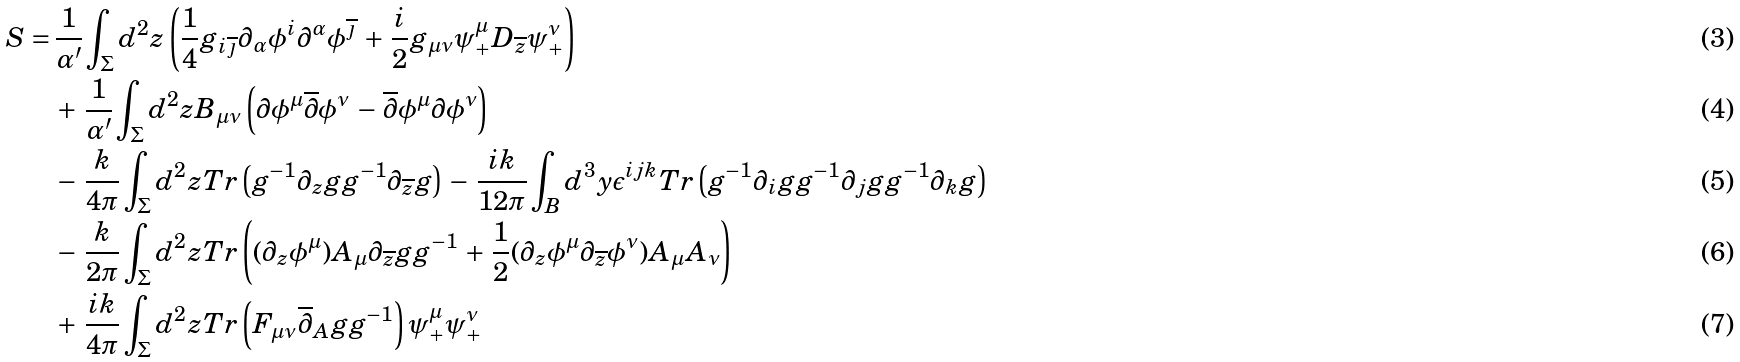<formula> <loc_0><loc_0><loc_500><loc_500>S = \, & \frac { 1 } { \alpha ^ { \prime } } \int _ { \Sigma } d ^ { 2 } z \left ( \frac { 1 } { 4 } g _ { i \overline { \jmath } } \partial _ { \alpha } \phi ^ { i } \partial ^ { \alpha } \phi ^ { \overline { \jmath } } \, + \, \frac { i } { 2 } g _ { \mu \nu } \psi _ { + } ^ { \mu } D _ { \overline { z } } \psi _ { + } ^ { \nu } \right ) \\ & + \, \frac { 1 } { \alpha ^ { \prime } } \int _ { \Sigma } d ^ { 2 } z B _ { \mu \nu } \left ( \partial \phi ^ { \mu } \overline { \partial } \phi ^ { \nu } \, - \, \overline { \partial } \phi ^ { \mu } \partial \phi ^ { \nu } \right ) \\ & - \, \frac { k } { 4 \pi } \int _ { \Sigma } d ^ { 2 } z T r \left ( g ^ { - 1 } \partial _ { z } g g ^ { - 1 } \partial _ { \overline { z } } g \right ) \, - \, \frac { i k } { 1 2 \pi } \int _ { B } d ^ { 3 } y \epsilon ^ { i j k } T r \left ( g ^ { - 1 } \partial _ { i } g g ^ { - 1 } \partial _ { j } g g ^ { - 1 } \partial _ { k } g \right ) \\ & - \, \frac { k } { 2 \pi } \int _ { \Sigma } d ^ { 2 } z T r \left ( ( \partial _ { z } \phi ^ { \mu } ) A _ { \mu } \partial _ { \overline { z } } g g ^ { - 1 } \, + \, \frac { 1 } { 2 } ( \partial _ { z } \phi ^ { \mu } \partial _ { \overline { z } } \phi ^ { \nu } ) A _ { \mu } A _ { \nu } \right ) \\ & + \, \frac { i k } { 4 \pi } \int _ { \Sigma } d ^ { 2 } z T r \left ( F _ { \mu \nu } \overline { \partial } _ { A } g g ^ { - 1 } \right ) \psi _ { + } ^ { \mu } \psi _ { + } ^ { \nu }</formula> 